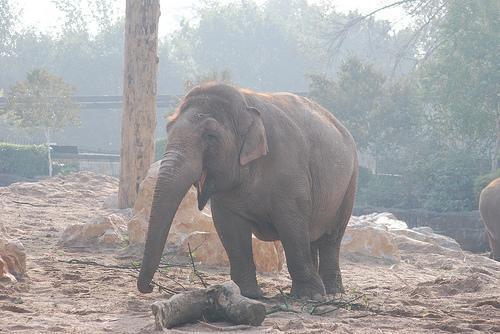How many animals?
Give a very brief answer. 2. 